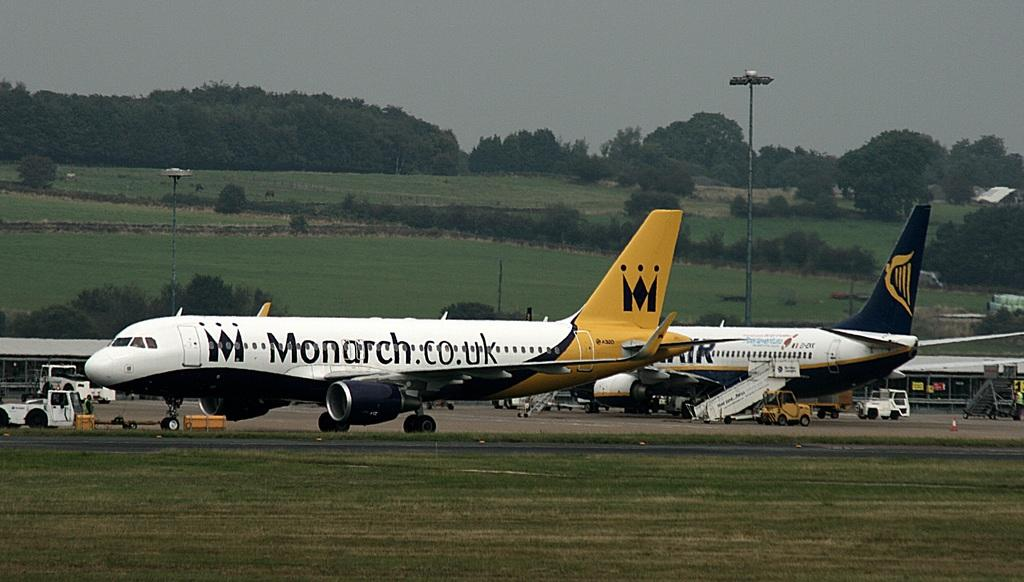<image>
Create a compact narrative representing the image presented. a few planes on the runway and one is monarch 